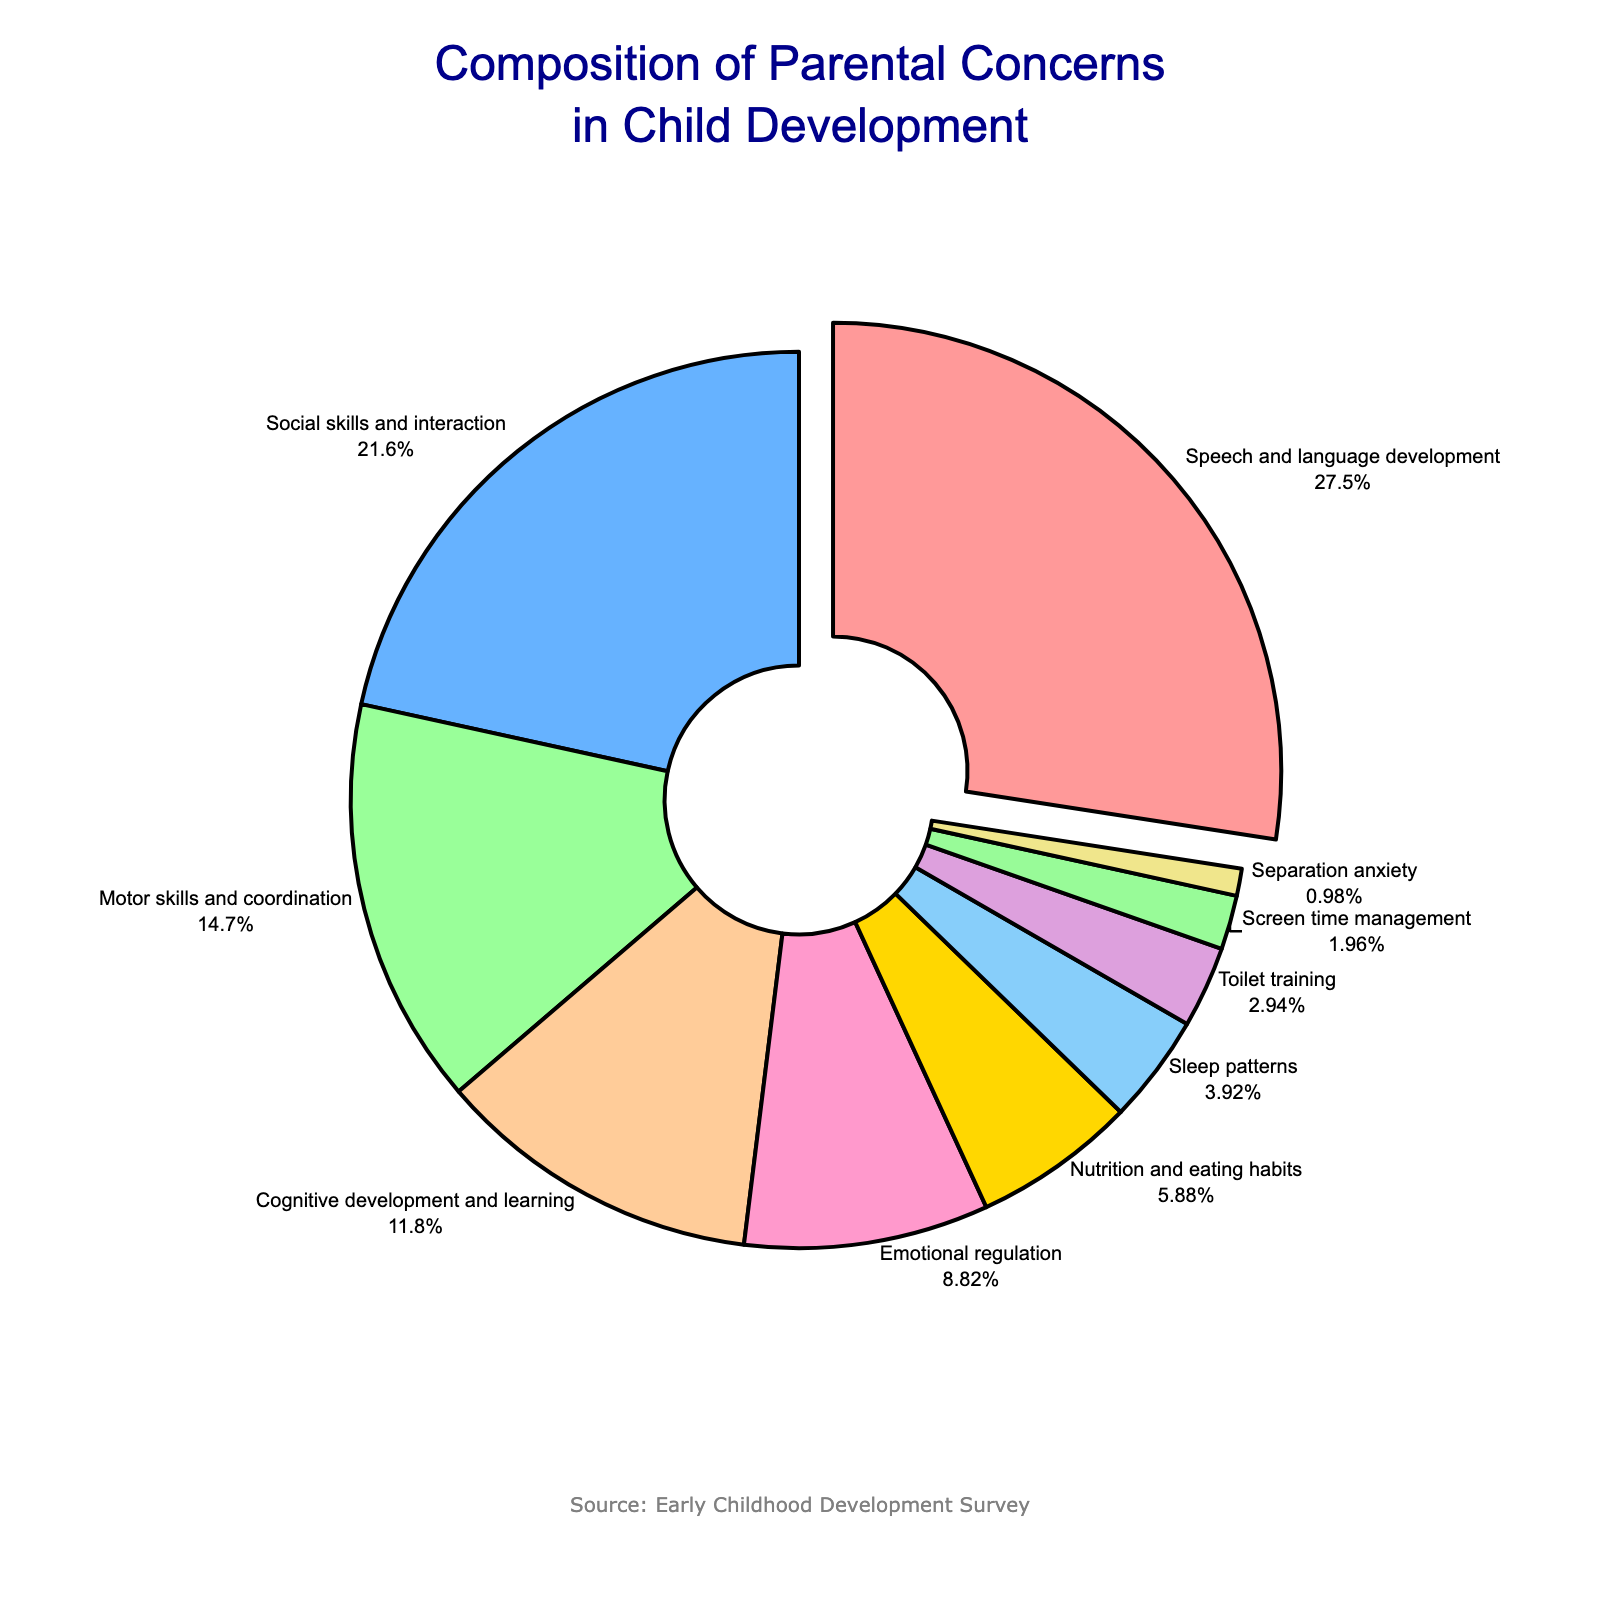What is the most common parental concern regarding child development? The largest slice of the pie chart represents the most common concern. The slice for "Speech and language development" is the largest, showing 28%.
Answer: Speech and language development How much greater is the concern for social skills and interaction compared to sleep patterns? The percentage for "Social skills and interaction" is 22%, while "Sleep patterns" is 4%. Subtract 4% from 22% to find the difference.
Answer: 18% Which concern covers a larger proportion: motor skills and coordination or cognitive development and learning? The pie chart shows "Motor skills and coordination" at 15% and "Cognitive development and learning" at 12%. Since 15% is greater than 12%, motor skills and coordination cover a larger proportion.
Answer: Motor skills and coordination What percentage of concerns are related to emotional regulation and nutrition combined? The chart shows "Emotional regulation" at 9% and "Nutrition and eating habits" at 6%. Add the two percentages together: 9% + 6%.
Answer: 15% Which parental concern is represented by the smallest slice, and what is its percentage? The smallest slice in the pie chart is "Separation anxiety," which is represented by 1%.
Answer: Separation anxiety, 1% How many times larger is the percentage of concern for speech and language development compared to screen time management? Speech and language development is 28%, and screen time management is 2%. Divide 28 by 2 to find how many times larger it is.
Answer: 14 times If you combine concerns about motor skills and coordination, toilet training, and screen time management, what is the total percentage? Add the percentages for "Motor skills and coordination" (15%), "Toilet training" (3%), and "Screen time management" (2%): 15% + 3% + 2%.
Answer: 20% Which color represents nutrition and eating habits, and what percentage does it cover? The pie chart uses a distinct color for each concern. Nutrition and eating habits are in yellow, and the percentage is 6%.
Answer: Yellow, 6% 